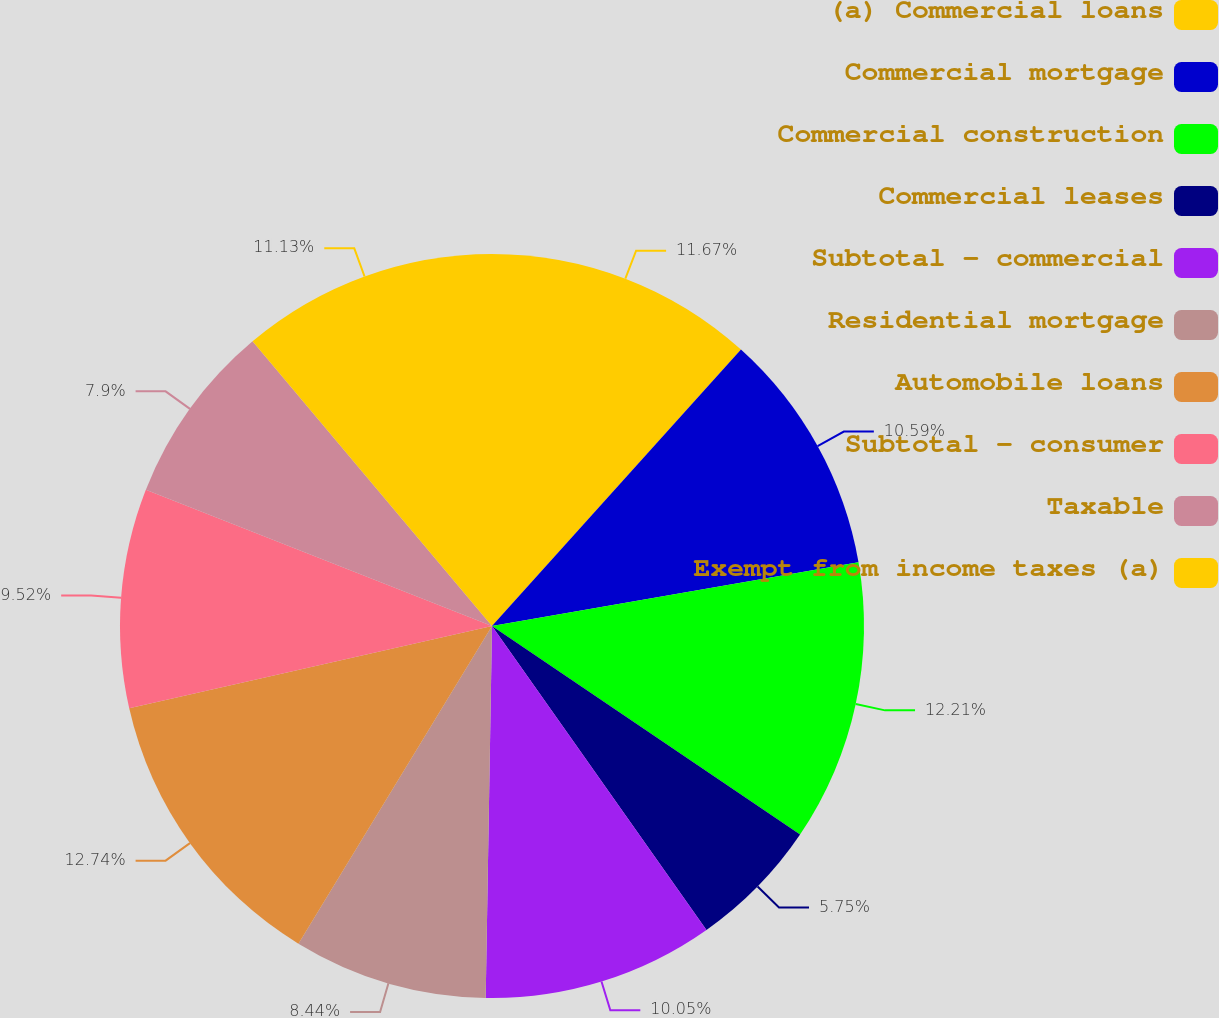<chart> <loc_0><loc_0><loc_500><loc_500><pie_chart><fcel>(a) Commercial loans<fcel>Commercial mortgage<fcel>Commercial construction<fcel>Commercial leases<fcel>Subtotal - commercial<fcel>Residential mortgage<fcel>Automobile loans<fcel>Subtotal - consumer<fcel>Taxable<fcel>Exempt from income taxes (a)<nl><fcel>11.67%<fcel>10.59%<fcel>12.21%<fcel>5.75%<fcel>10.05%<fcel>8.44%<fcel>12.74%<fcel>9.52%<fcel>7.9%<fcel>11.13%<nl></chart> 